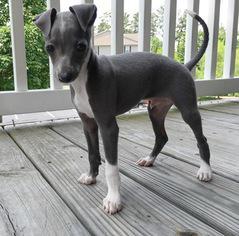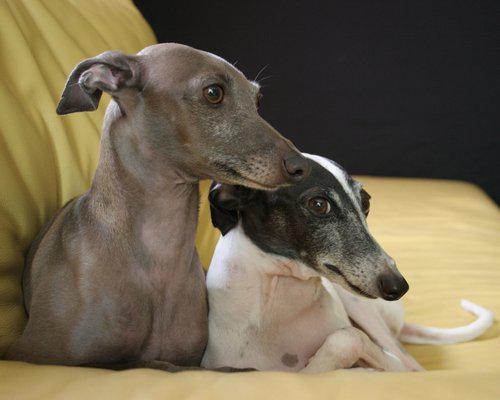The first image is the image on the left, the second image is the image on the right. Evaluate the accuracy of this statement regarding the images: "One of the dogs is in green vegetation.". Is it true? Answer yes or no. No. The first image is the image on the left, the second image is the image on the right. Considering the images on both sides, is "There are more hound dogs in the right image than in the left." valid? Answer yes or no. Yes. 